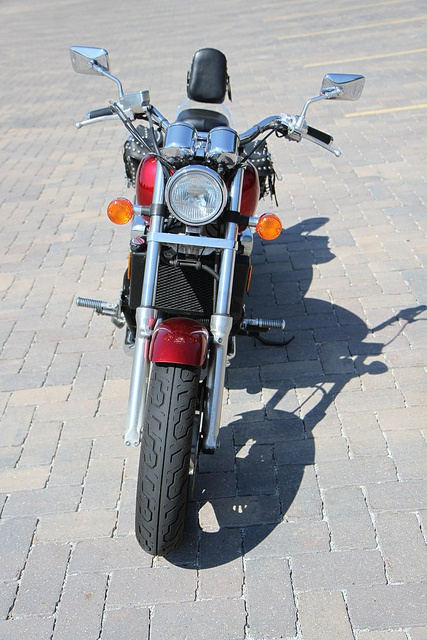Describe the objects in this image and their specific colors. I can see a motorcycle in darkgray, black, gray, and lightgray tones in this image. 